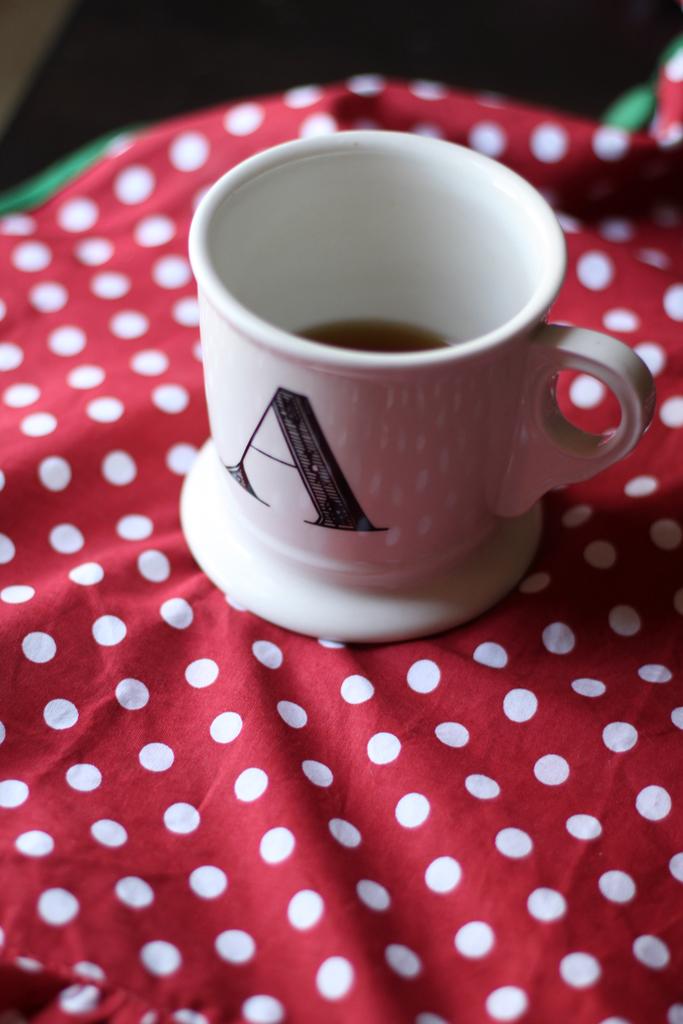What letter is on the mug?
Provide a short and direct response. A. 